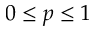Convert formula to latex. <formula><loc_0><loc_0><loc_500><loc_500>0 \leq p \leq 1</formula> 